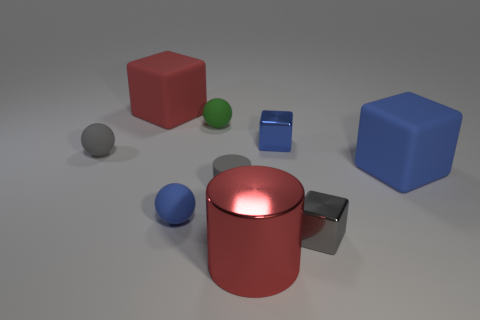Subtract all small blue balls. How many balls are left? 2 Add 1 blue shiny cylinders. How many objects exist? 10 Subtract all red spheres. How many blue cubes are left? 2 Subtract all red cubes. How many cubes are left? 3 Subtract 1 blocks. How many blocks are left? 3 Subtract all small purple shiny cubes. Subtract all tiny green rubber objects. How many objects are left? 8 Add 5 red rubber cubes. How many red rubber cubes are left? 6 Add 9 big cylinders. How many big cylinders exist? 10 Subtract 0 yellow spheres. How many objects are left? 9 Subtract all cylinders. How many objects are left? 7 